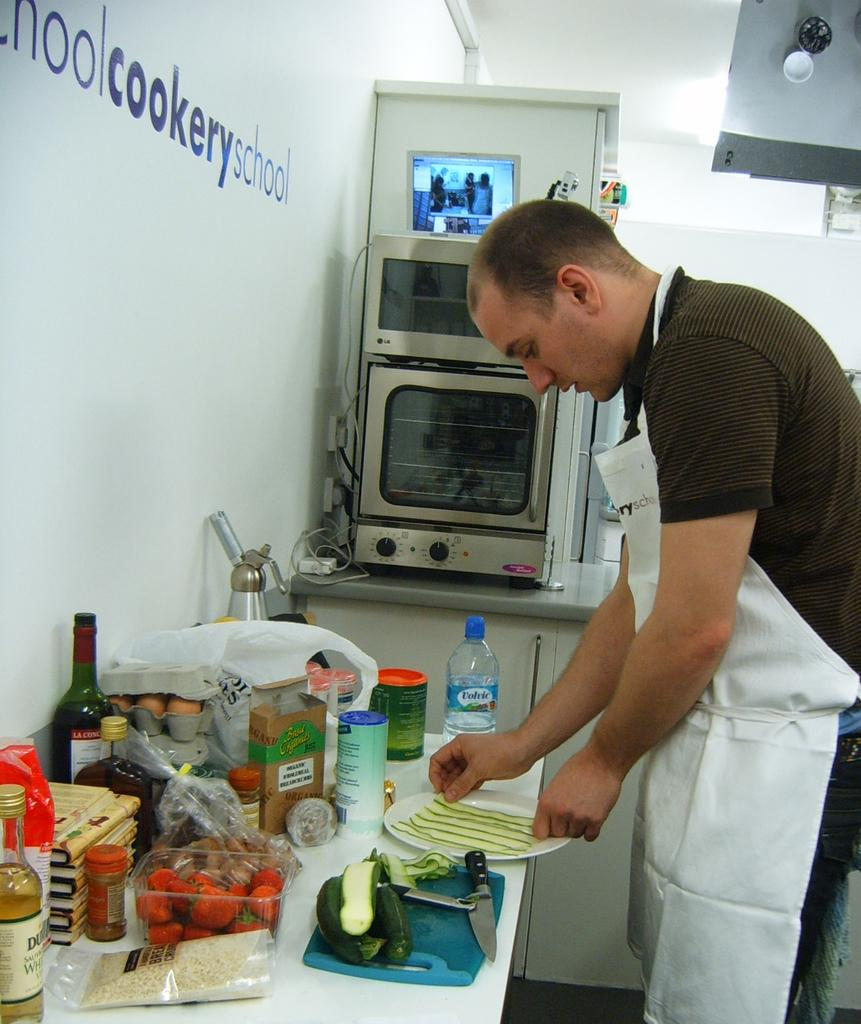Provide a one-sentence caption for the provided image. A man prepares food next to a wall that says "cookery school.". 